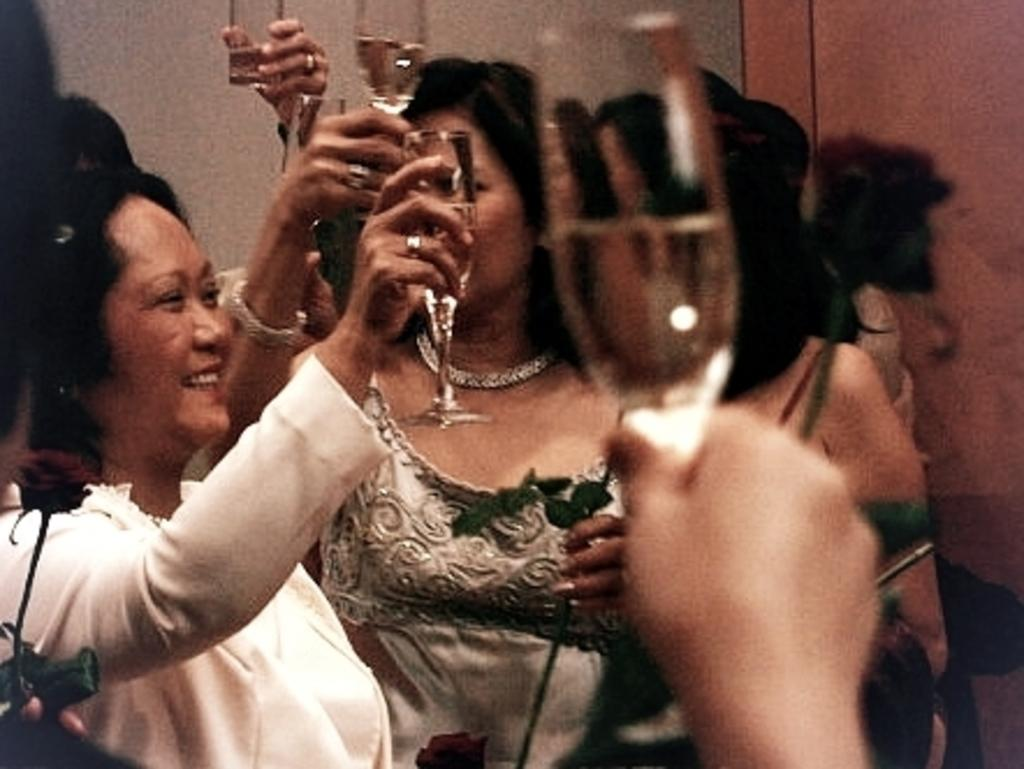Who is present in the image? There are women in the image. What expression do the women have? The women are smiling. What are the women holding in their hands? The women are holding glasses in their hands. What can be seen in the background of the image? There is a wall in the background of the image. What type of flowers can be seen growing on the lace in the image? There are no flowers or lace present in the image; it features women holding glasses and a wall in the background. 